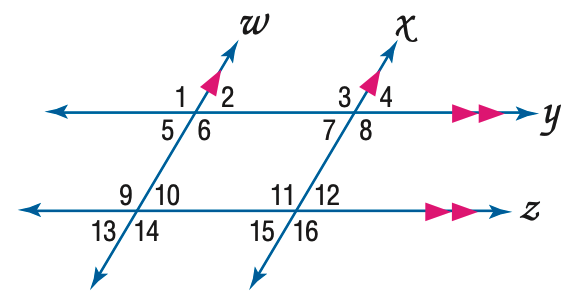Answer the mathemtical geometry problem and directly provide the correct option letter.
Question: In the figure, m \angle 12 = 64. Find the measure of \angle 4.
Choices: A: 64 B: 66 C: 74 D: 76 A 